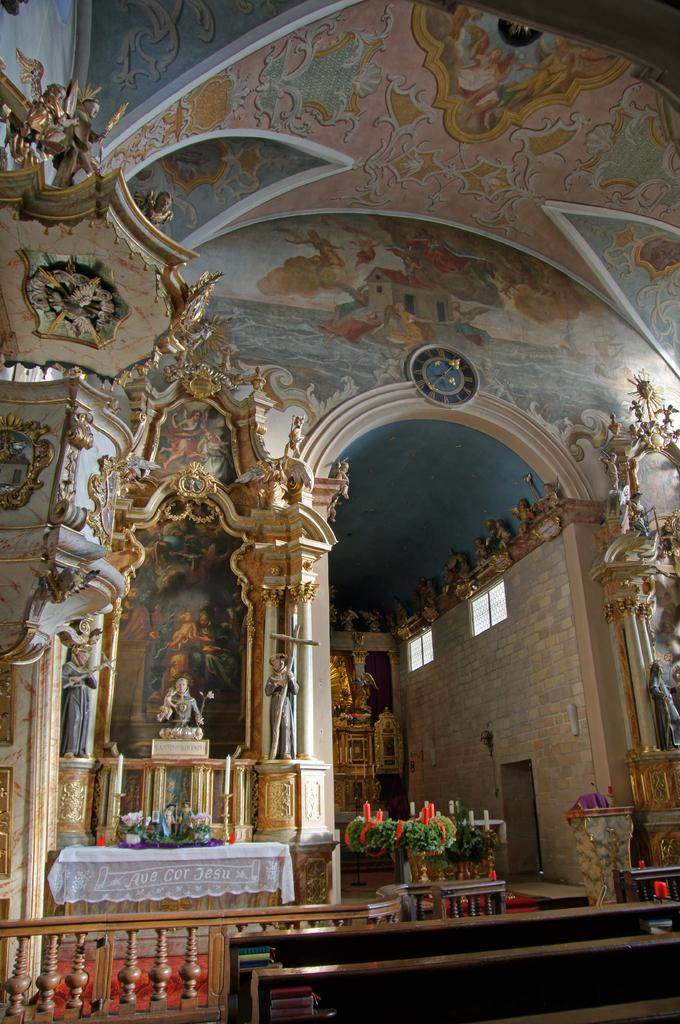What architectural feature can be seen in the image? There are balusters in the image. What type of material is present in the image? There is cloth in the image. What type of vegetation is present in the image? Decorative plants are present in the image. What type of artwork is visible in the image? Sculptures are visible in the image. Where are the paintings located in the image? Paintings are on the ceiling in the image. What advice is given in the image? There is no advice present in the image; it contains balusters, cloth, decorative plants, sculptures, and paintings on the ceiling. What time of day is depicted in the image? The time of day is not depicted in the image; it only shows the mentioned objects and subjects. 